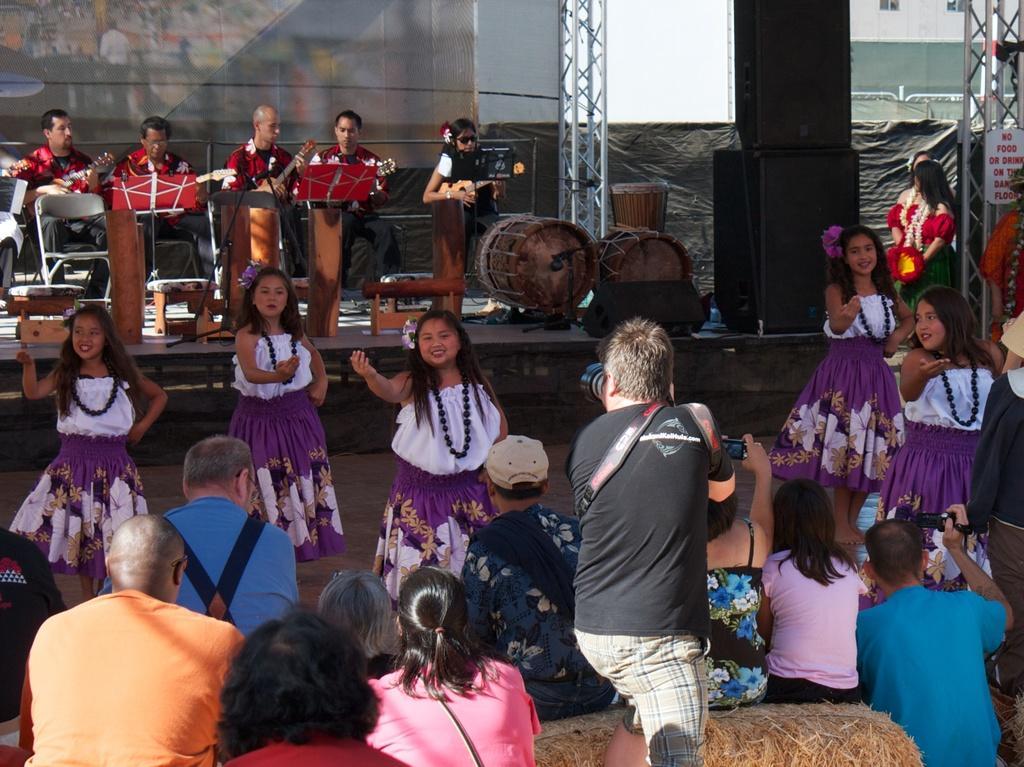Describe this image in one or two sentences. In this image we can see the girls dancing. We can also see the people sitting on the dried grass. We can also see a man holding the camera and standing. In the background we can see the stage and we can also see the people playing the musical instruments. We can see the drums, some rods, board, display screen and also the empty chairs. On the right we can see the building, sound boxes, text boards and also some rods and people. 